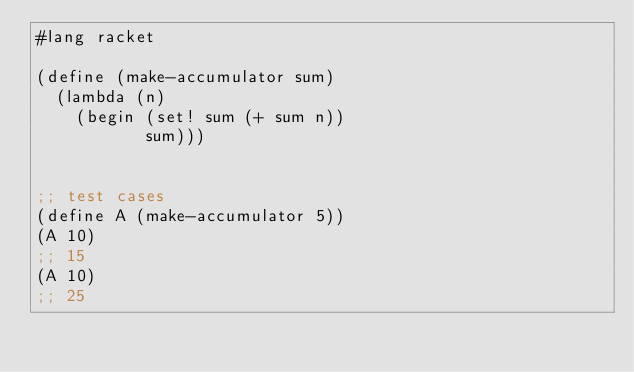<code> <loc_0><loc_0><loc_500><loc_500><_Scheme_>#lang racket

(define (make-accumulator sum)
  (lambda (n) 
    (begin (set! sum (+ sum n)) 
           sum)))


;; test cases
(define A (make-accumulator 5))
(A 10)
;; 15
(A 10)
;; 25
</code> 